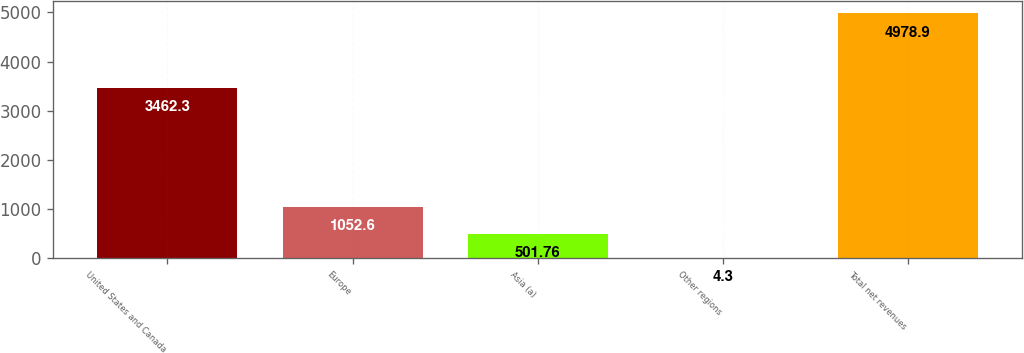Convert chart to OTSL. <chart><loc_0><loc_0><loc_500><loc_500><bar_chart><fcel>United States and Canada<fcel>Europe<fcel>Asia (a)<fcel>Other regions<fcel>Total net revenues<nl><fcel>3462.3<fcel>1052.6<fcel>501.76<fcel>4.3<fcel>4978.9<nl></chart> 